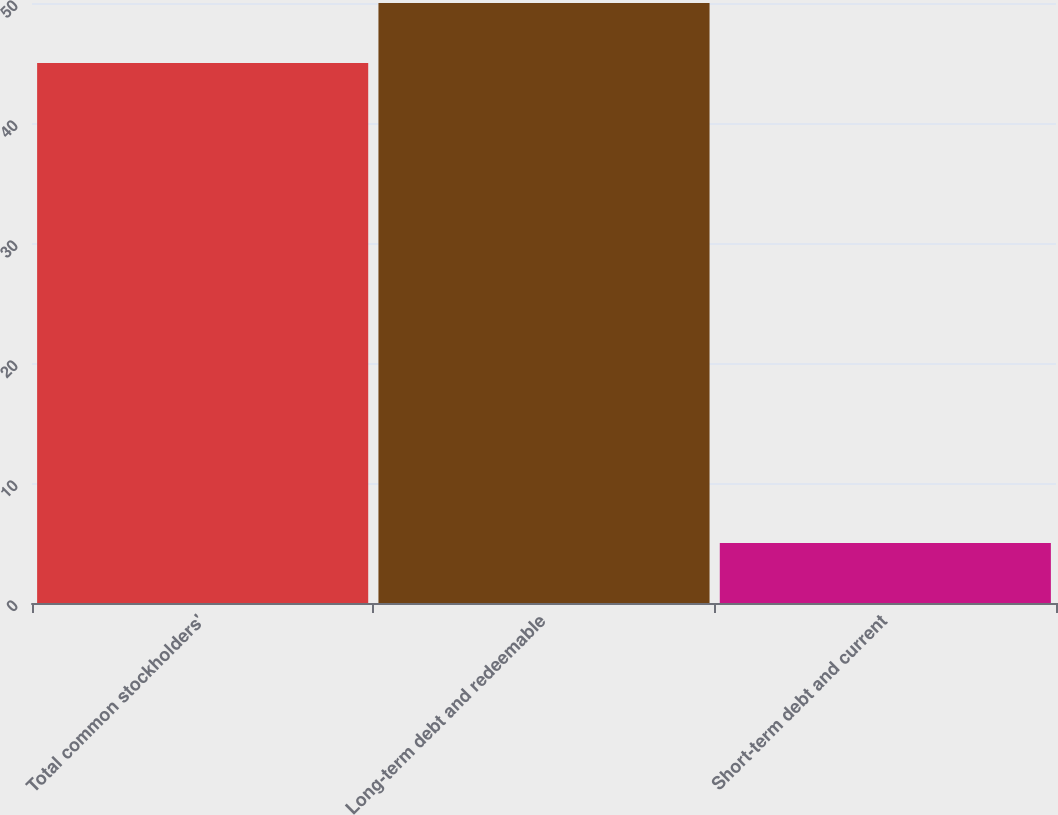Convert chart. <chart><loc_0><loc_0><loc_500><loc_500><bar_chart><fcel>Total common stockholders'<fcel>Long-term debt and redeemable<fcel>Short-term debt and current<nl><fcel>45<fcel>50<fcel>5<nl></chart> 